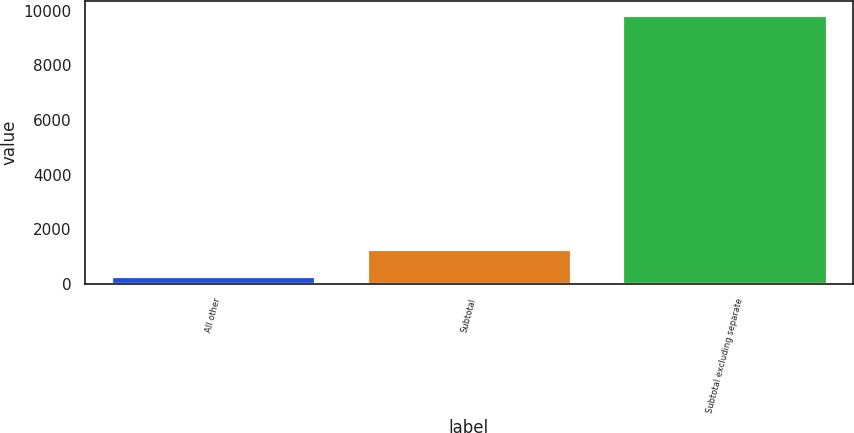<chart> <loc_0><loc_0><loc_500><loc_500><bar_chart><fcel>All other<fcel>Subtotal<fcel>Subtotal excluding separate<nl><fcel>297<fcel>1253.3<fcel>9860<nl></chart> 